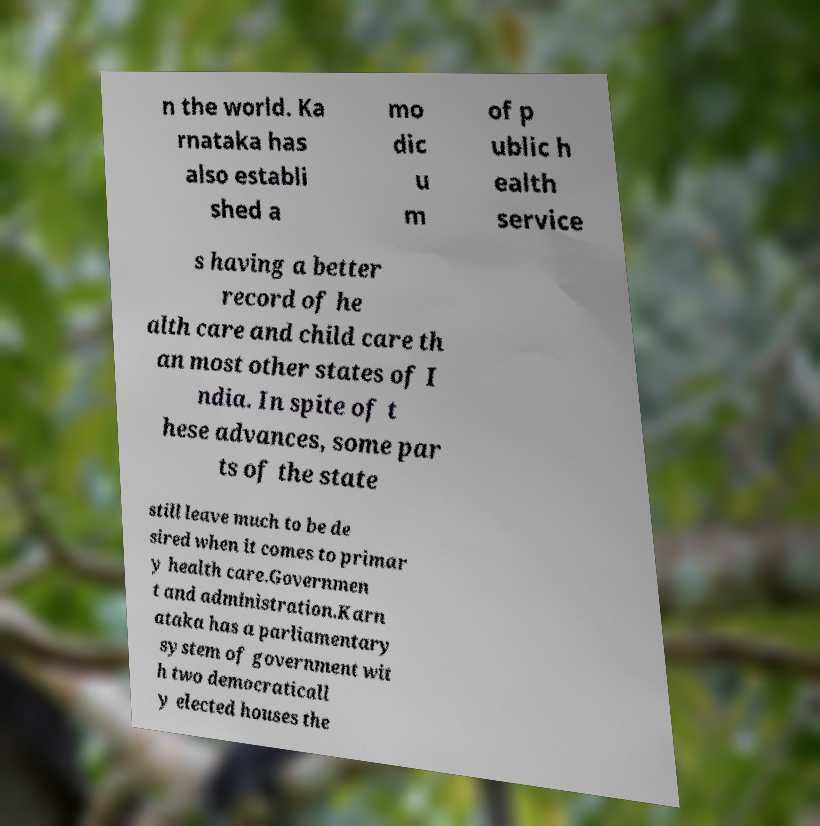Please read and relay the text visible in this image. What does it say? n the world. Ka rnataka has also establi shed a mo dic u m of p ublic h ealth service s having a better record of he alth care and child care th an most other states of I ndia. In spite of t hese advances, some par ts of the state still leave much to be de sired when it comes to primar y health care.Governmen t and administration.Karn ataka has a parliamentary system of government wit h two democraticall y elected houses the 